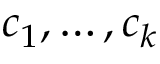Convert formula to latex. <formula><loc_0><loc_0><loc_500><loc_500>c _ { 1 } , \dots , c _ { k }</formula> 